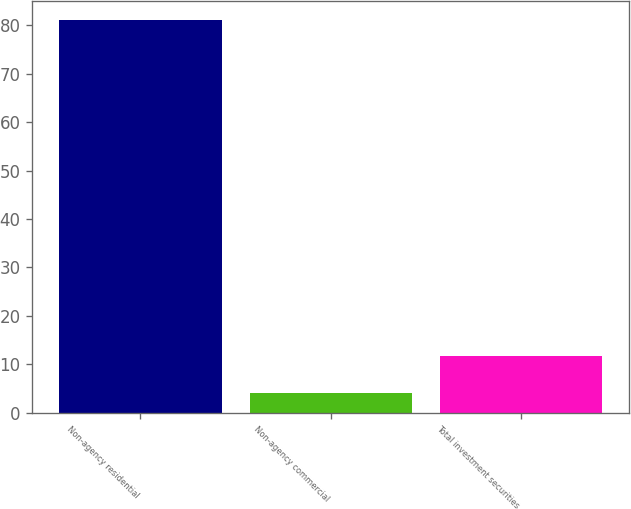Convert chart. <chart><loc_0><loc_0><loc_500><loc_500><bar_chart><fcel>Non-agency residential<fcel>Non-agency commercial<fcel>Total investment securities<nl><fcel>81<fcel>4<fcel>11.7<nl></chart> 